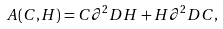Convert formula to latex. <formula><loc_0><loc_0><loc_500><loc_500>A ( C , H ) = C \partial ^ { 2 } D H + H \partial ^ { 2 } D C ,</formula> 